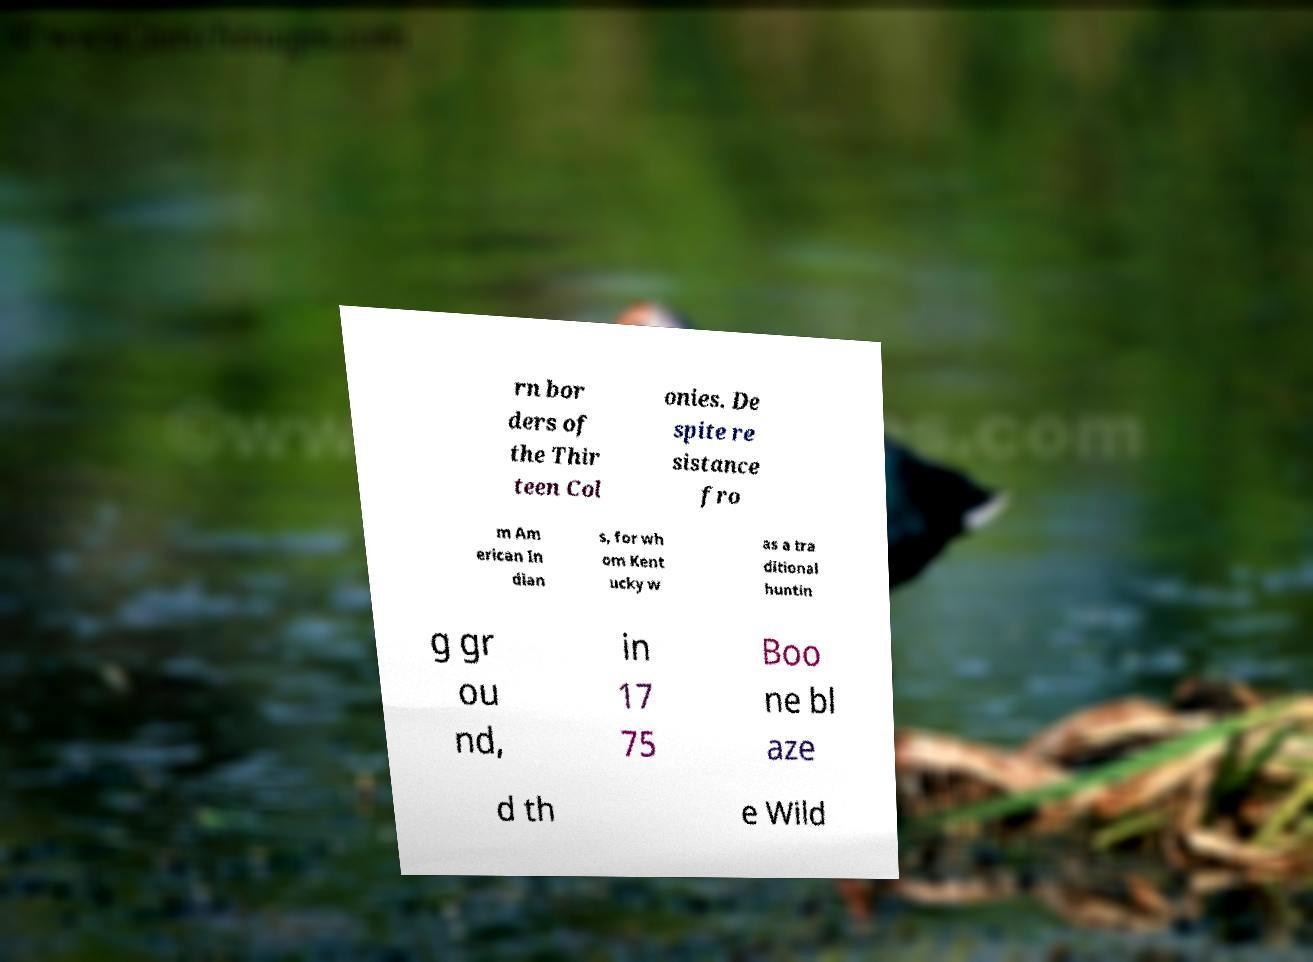Can you read and provide the text displayed in the image?This photo seems to have some interesting text. Can you extract and type it out for me? rn bor ders of the Thir teen Col onies. De spite re sistance fro m Am erican In dian s, for wh om Kent ucky w as a tra ditional huntin g gr ou nd, in 17 75 Boo ne bl aze d th e Wild 